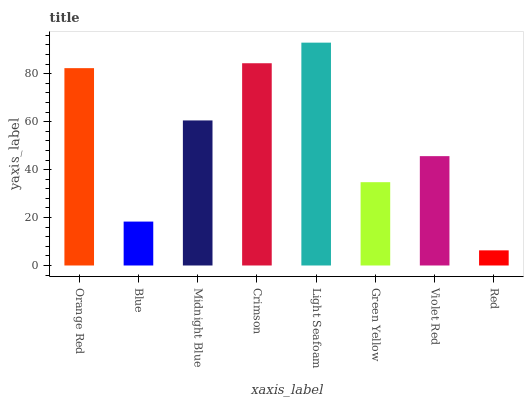Is Blue the minimum?
Answer yes or no. No. Is Blue the maximum?
Answer yes or no. No. Is Orange Red greater than Blue?
Answer yes or no. Yes. Is Blue less than Orange Red?
Answer yes or no. Yes. Is Blue greater than Orange Red?
Answer yes or no. No. Is Orange Red less than Blue?
Answer yes or no. No. Is Midnight Blue the high median?
Answer yes or no. Yes. Is Violet Red the low median?
Answer yes or no. Yes. Is Blue the high median?
Answer yes or no. No. Is Midnight Blue the low median?
Answer yes or no. No. 